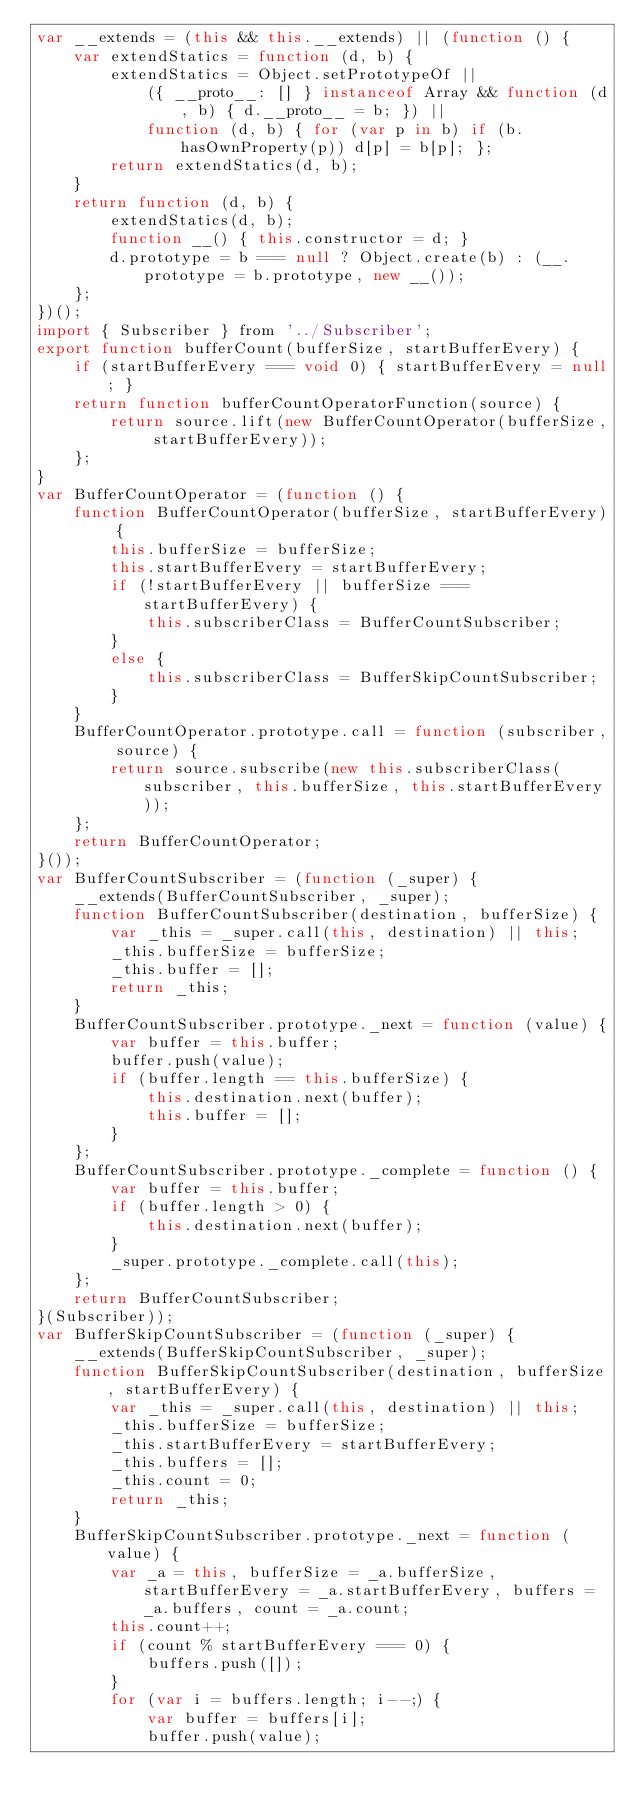Convert code to text. <code><loc_0><loc_0><loc_500><loc_500><_JavaScript_>var __extends = (this && this.__extends) || (function () {
    var extendStatics = function (d, b) {
        extendStatics = Object.setPrototypeOf ||
            ({ __proto__: [] } instanceof Array && function (d, b) { d.__proto__ = b; }) ||
            function (d, b) { for (var p in b) if (b.hasOwnProperty(p)) d[p] = b[p]; };
        return extendStatics(d, b);
    }
    return function (d, b) {
        extendStatics(d, b);
        function __() { this.constructor = d; }
        d.prototype = b === null ? Object.create(b) : (__.prototype = b.prototype, new __());
    };
})();
import { Subscriber } from '../Subscriber';
export function bufferCount(bufferSize, startBufferEvery) {
    if (startBufferEvery === void 0) { startBufferEvery = null; }
    return function bufferCountOperatorFunction(source) {
        return source.lift(new BufferCountOperator(bufferSize, startBufferEvery));
    };
}
var BufferCountOperator = (function () {
    function BufferCountOperator(bufferSize, startBufferEvery) {
        this.bufferSize = bufferSize;
        this.startBufferEvery = startBufferEvery;
        if (!startBufferEvery || bufferSize === startBufferEvery) {
            this.subscriberClass = BufferCountSubscriber;
        }
        else {
            this.subscriberClass = BufferSkipCountSubscriber;
        }
    }
    BufferCountOperator.prototype.call = function (subscriber, source) {
        return source.subscribe(new this.subscriberClass(subscriber, this.bufferSize, this.startBufferEvery));
    };
    return BufferCountOperator;
}());
var BufferCountSubscriber = (function (_super) {
    __extends(BufferCountSubscriber, _super);
    function BufferCountSubscriber(destination, bufferSize) {
        var _this = _super.call(this, destination) || this;
        _this.bufferSize = bufferSize;
        _this.buffer = [];
        return _this;
    }
    BufferCountSubscriber.prototype._next = function (value) {
        var buffer = this.buffer;
        buffer.push(value);
        if (buffer.length == this.bufferSize) {
            this.destination.next(buffer);
            this.buffer = [];
        }
    };
    BufferCountSubscriber.prototype._complete = function () {
        var buffer = this.buffer;
        if (buffer.length > 0) {
            this.destination.next(buffer);
        }
        _super.prototype._complete.call(this);
    };
    return BufferCountSubscriber;
}(Subscriber));
var BufferSkipCountSubscriber = (function (_super) {
    __extends(BufferSkipCountSubscriber, _super);
    function BufferSkipCountSubscriber(destination, bufferSize, startBufferEvery) {
        var _this = _super.call(this, destination) || this;
        _this.bufferSize = bufferSize;
        _this.startBufferEvery = startBufferEvery;
        _this.buffers = [];
        _this.count = 0;
        return _this;
    }
    BufferSkipCountSubscriber.prototype._next = function (value) {
        var _a = this, bufferSize = _a.bufferSize, startBufferEvery = _a.startBufferEvery, buffers = _a.buffers, count = _a.count;
        this.count++;
        if (count % startBufferEvery === 0) {
            buffers.push([]);
        }
        for (var i = buffers.length; i--;) {
            var buffer = buffers[i];
            buffer.push(value);</code> 